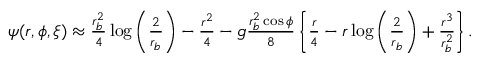<formula> <loc_0><loc_0><loc_500><loc_500>\begin{array} { r } { \psi ( r , \phi , \xi ) \approx \frac { r _ { b } ^ { 2 } } { 4 } \log \left ( \frac { 2 } { r _ { b } } \right ) - \frac { r ^ { 2 } } { 4 } - g \frac { r _ { b } ^ { 2 } \cos \phi } { 8 } \left \{ \frac { r } { 4 } - r \log \left ( \frac { 2 } { r _ { b } } \right ) + \frac { r ^ { 3 } } { r _ { b } ^ { 2 } } \right \} . } \end{array}</formula> 